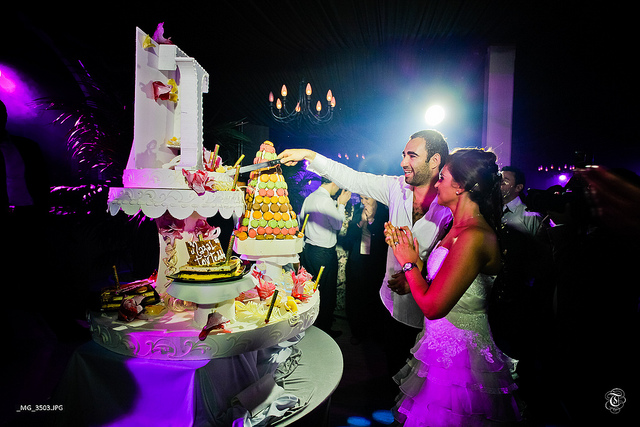Extract all visible text content from this image. MG 3503 